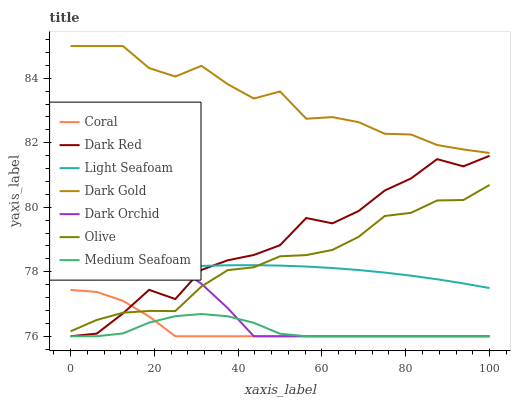Does Medium Seafoam have the minimum area under the curve?
Answer yes or no. Yes. Does Dark Gold have the maximum area under the curve?
Answer yes or no. Yes. Does Dark Red have the minimum area under the curve?
Answer yes or no. No. Does Dark Red have the maximum area under the curve?
Answer yes or no. No. Is Light Seafoam the smoothest?
Answer yes or no. Yes. Is Dark Red the roughest?
Answer yes or no. Yes. Is Coral the smoothest?
Answer yes or no. No. Is Coral the roughest?
Answer yes or no. No. Does Dark Red have the lowest value?
Answer yes or no. Yes. Does Olive have the lowest value?
Answer yes or no. No. Does Dark Gold have the highest value?
Answer yes or no. Yes. Does Dark Red have the highest value?
Answer yes or no. No. Is Medium Seafoam less than Olive?
Answer yes or no. Yes. Is Dark Gold greater than Dark Orchid?
Answer yes or no. Yes. Does Dark Orchid intersect Coral?
Answer yes or no. Yes. Is Dark Orchid less than Coral?
Answer yes or no. No. Is Dark Orchid greater than Coral?
Answer yes or no. No. Does Medium Seafoam intersect Olive?
Answer yes or no. No. 